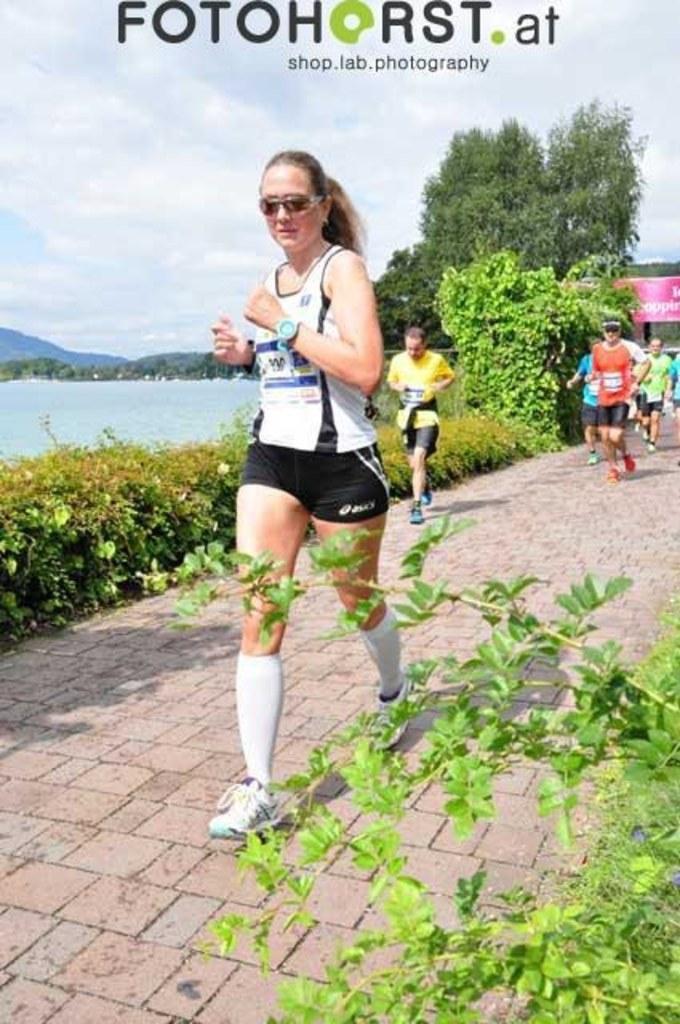Describe this image in one or two sentences. In this image there is a running track, people are running on the running, beside the running track there are plants and trees, beside the plants there is a lake in the background there are mountains and a sky. 